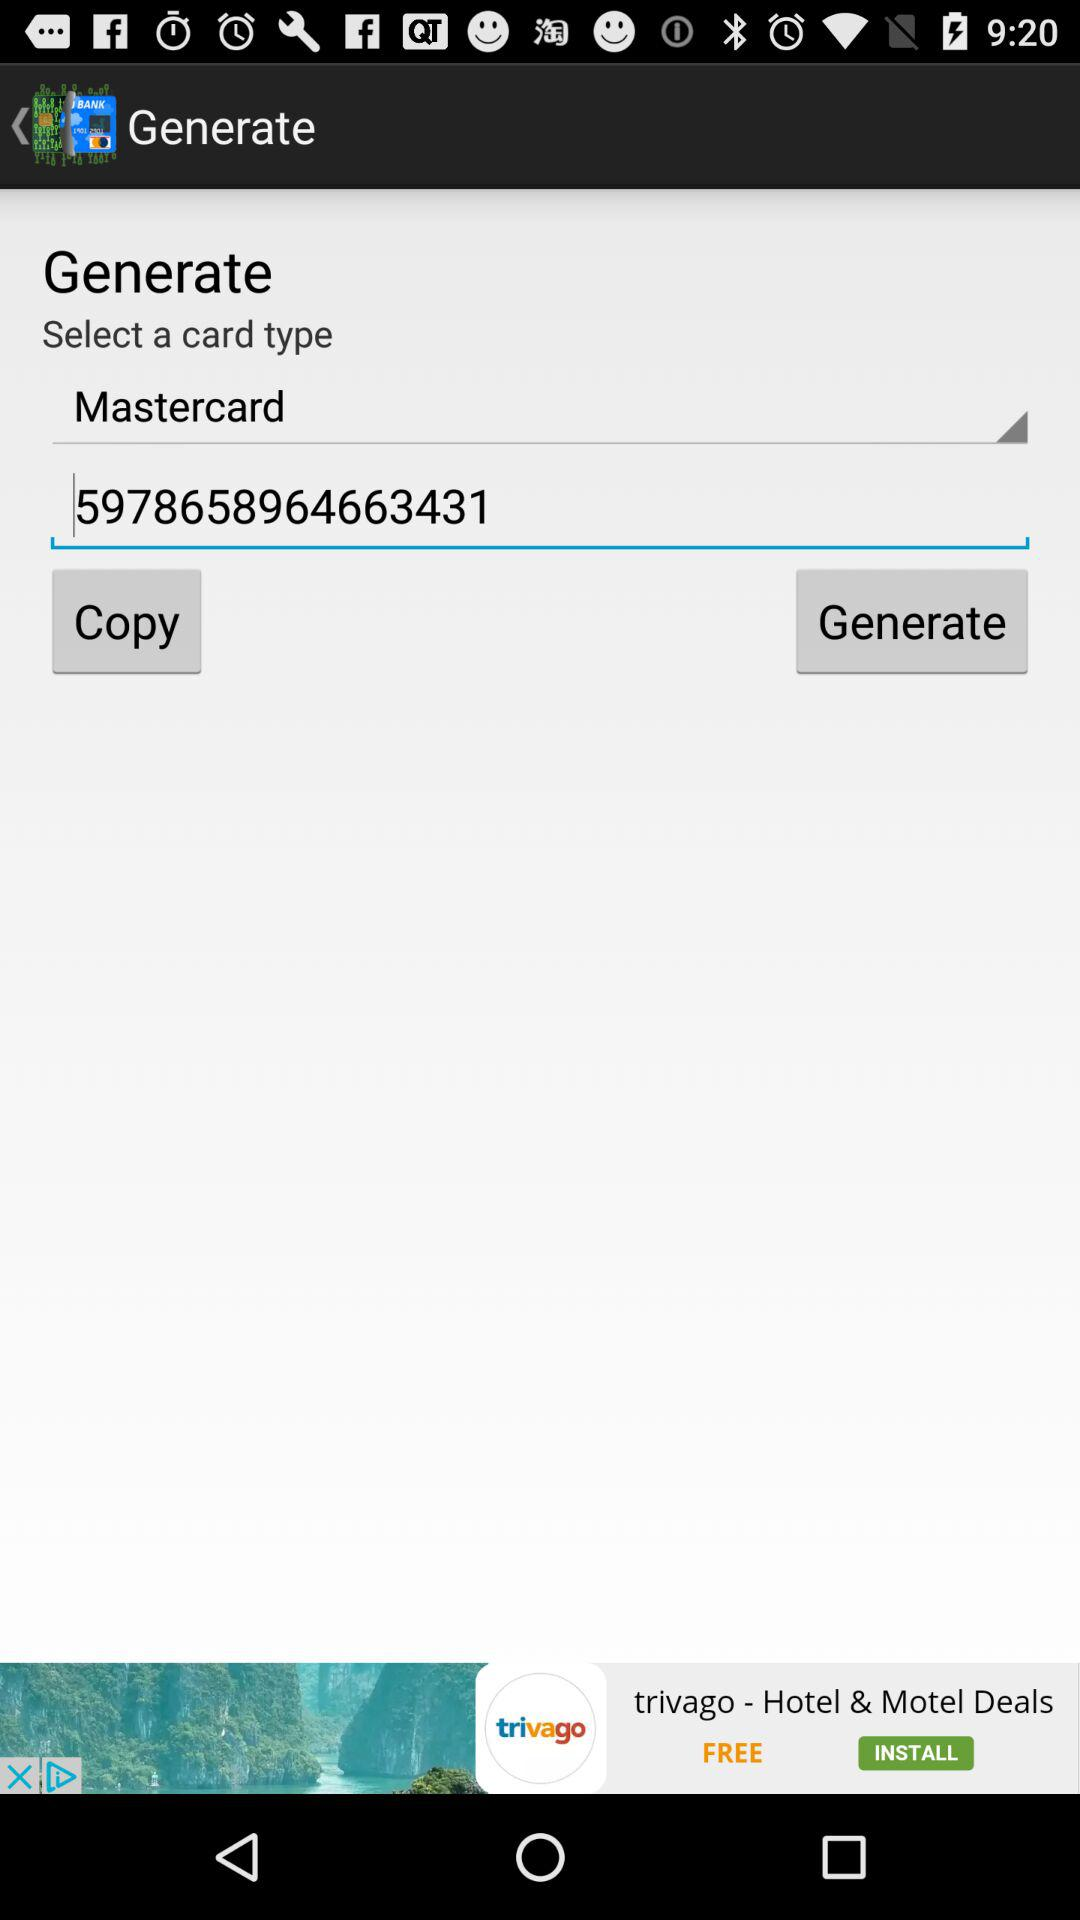What is the number of the card? The number of the card is 5978658964663431. 